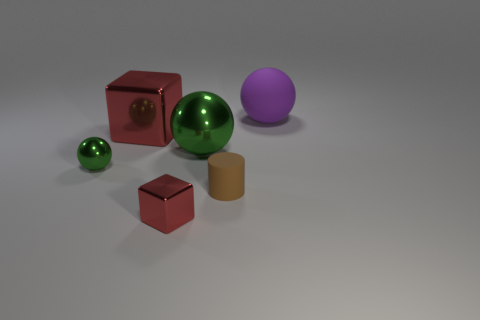What number of big metal things have the same color as the tiny metal sphere?
Ensure brevity in your answer.  1. The object that is the same color as the small sphere is what size?
Make the answer very short. Large. Is the thing that is right of the tiny matte cylinder made of the same material as the large red block?
Offer a very short reply. No. What number of balls are either purple rubber objects or small red metallic things?
Keep it short and to the point. 1. What shape is the small shiny thing that is on the right side of the big cube behind the tiny metallic thing that is left of the big metallic cube?
Offer a terse response. Cube. What shape is the shiny thing that is the same color as the small ball?
Your answer should be compact. Sphere. What number of other objects are the same size as the brown object?
Keep it short and to the point. 2. Is there a large green thing in front of the matte thing that is to the left of the big purple object?
Make the answer very short. No. How many things are either big yellow metallic blocks or big green shiny objects?
Make the answer very short. 1. There is a rubber thing in front of the metallic sphere in front of the large ball in front of the purple ball; what is its color?
Make the answer very short. Brown. 